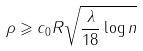<formula> <loc_0><loc_0><loc_500><loc_500>\rho \geqslant c _ { 0 } R \sqrt { \frac { \lambda } { 1 8 } \log n }</formula> 